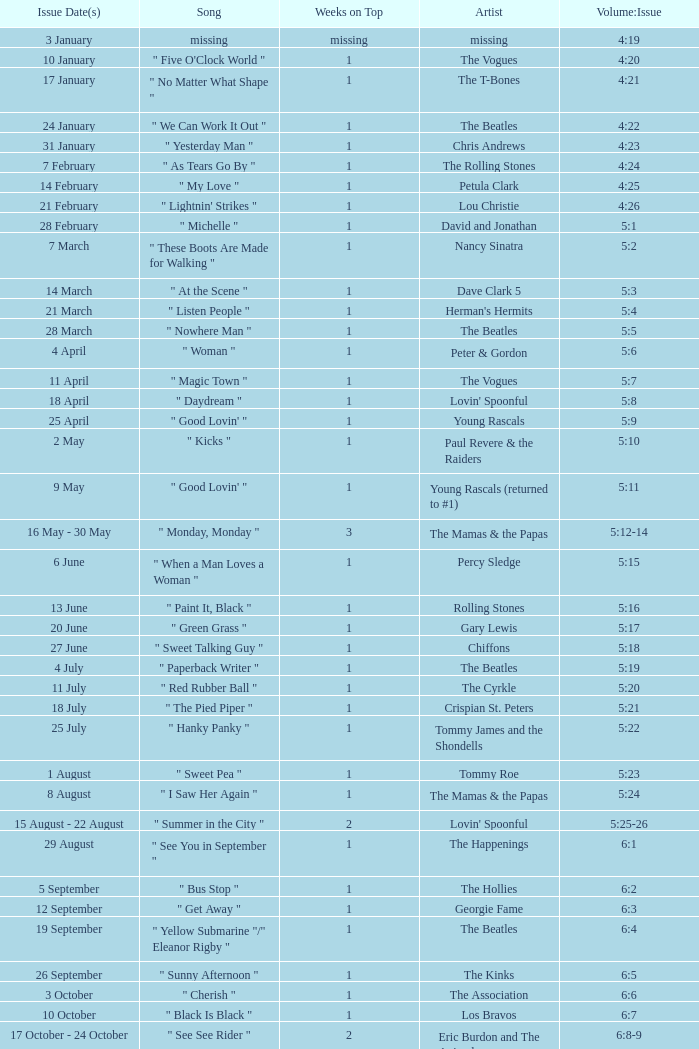An artist of the Beatles with an issue date(s) of 19 September has what as the listed weeks on top? 1.0. 